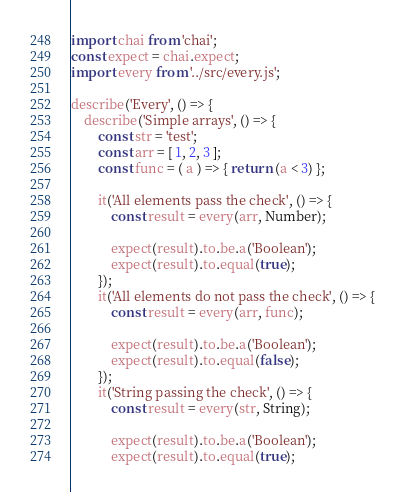Convert code to text. <code><loc_0><loc_0><loc_500><loc_500><_JavaScript_>import chai from 'chai';
const expect = chai.expect;
import every from '../src/every.js';

describe('Every', () => {
    describe('Simple arrays', () => {
        const str = 'test';
        const arr = [ 1, 2, 3 ];
        const func = ( a ) => { return (a < 3) };

        it('All elements pass the check', () => {
            const result = every(arr, Number);

            expect(result).to.be.a('Boolean');
            expect(result).to.equal(true);
        });
        it('All elements do not pass the check', () => {
            const result = every(arr, func);

            expect(result).to.be.a('Boolean');
            expect(result).to.equal(false);
        });
        it('String passing the check', () => {
            const result = every(str, String);

            expect(result).to.be.a('Boolean');
            expect(result).to.equal(true);</code> 